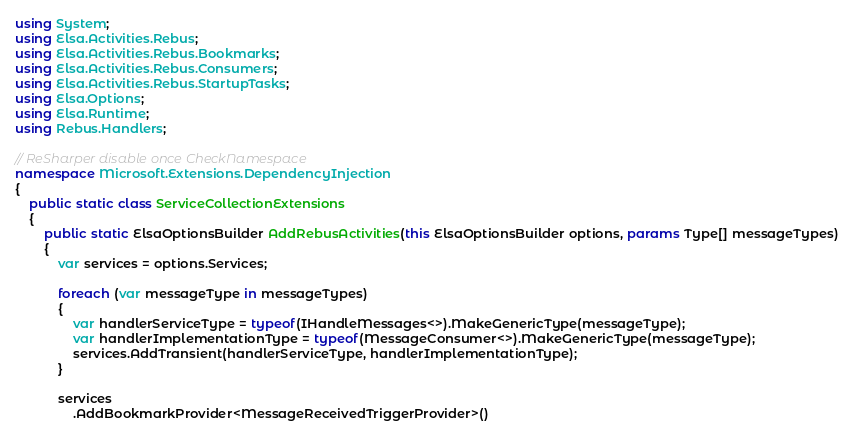Convert code to text. <code><loc_0><loc_0><loc_500><loc_500><_C#_>using System;
using Elsa.Activities.Rebus;
using Elsa.Activities.Rebus.Bookmarks;
using Elsa.Activities.Rebus.Consumers;
using Elsa.Activities.Rebus.StartupTasks;
using Elsa.Options;
using Elsa.Runtime;
using Rebus.Handlers;

// ReSharper disable once CheckNamespace
namespace Microsoft.Extensions.DependencyInjection
{
    public static class ServiceCollectionExtensions
    {
        public static ElsaOptionsBuilder AddRebusActivities(this ElsaOptionsBuilder options, params Type[] messageTypes)
        {
            var services = options.Services;

            foreach (var messageType in messageTypes)
            {
                var handlerServiceType = typeof(IHandleMessages<>).MakeGenericType(messageType);
                var handlerImplementationType = typeof(MessageConsumer<>).MakeGenericType(messageType);
                services.AddTransient(handlerServiceType, handlerImplementationType);
            }

            services
                .AddBookmarkProvider<MessageReceivedTriggerProvider>()</code> 